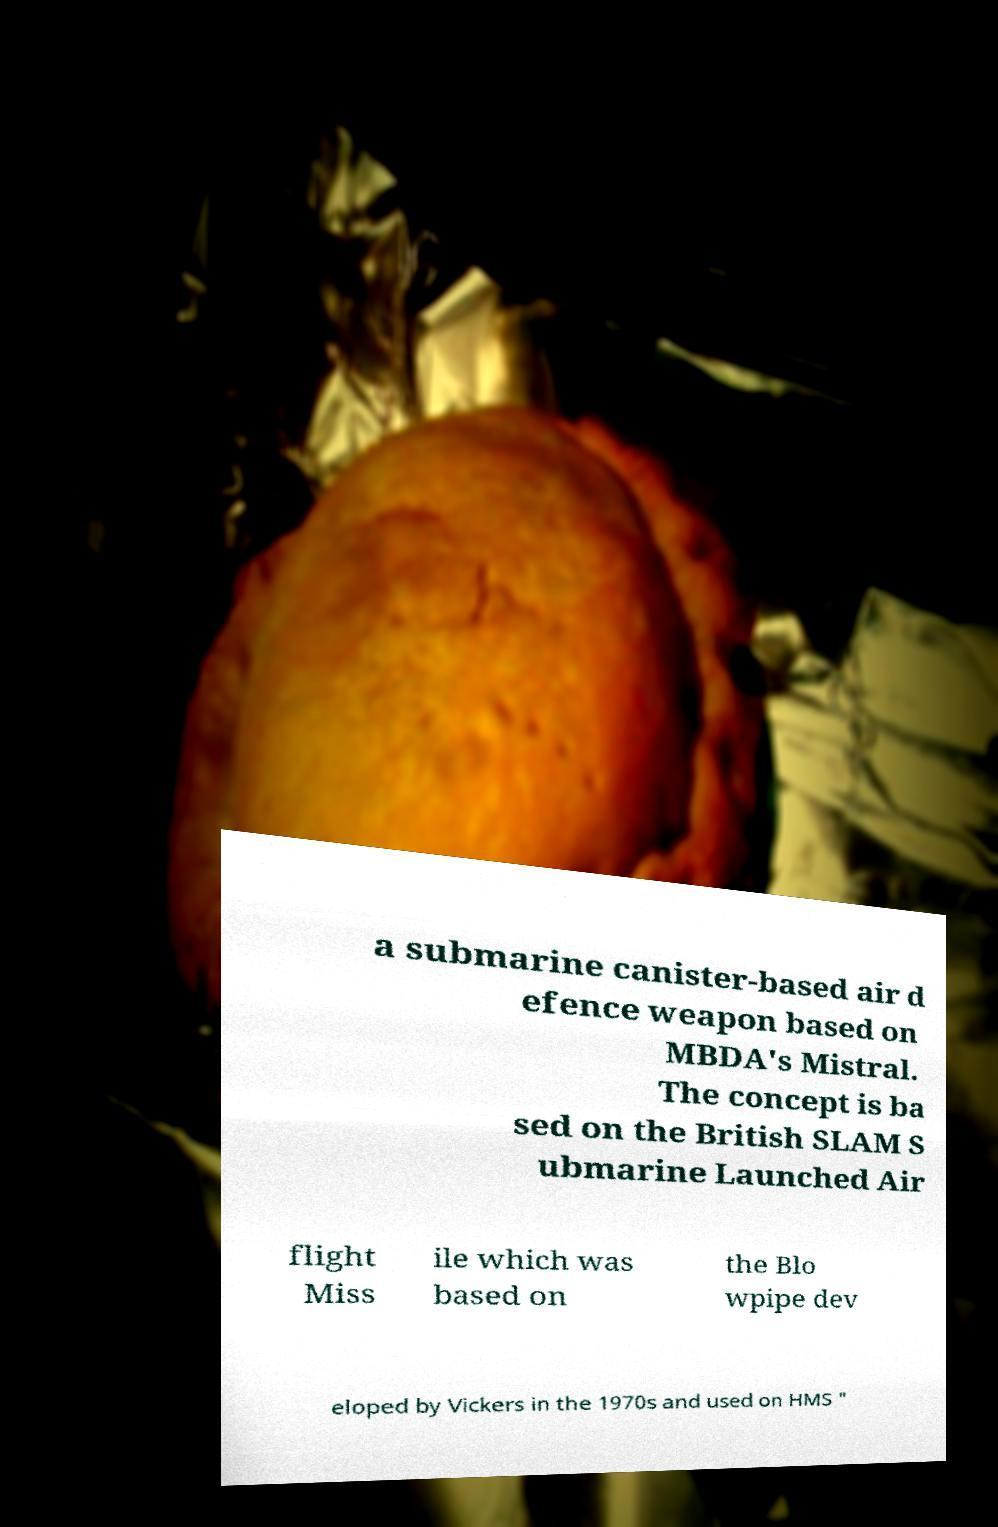Please read and relay the text visible in this image. What does it say? a submarine canister-based air d efence weapon based on MBDA's Mistral. The concept is ba sed on the British SLAM S ubmarine Launched Air flight Miss ile which was based on the Blo wpipe dev eloped by Vickers in the 1970s and used on HMS " 